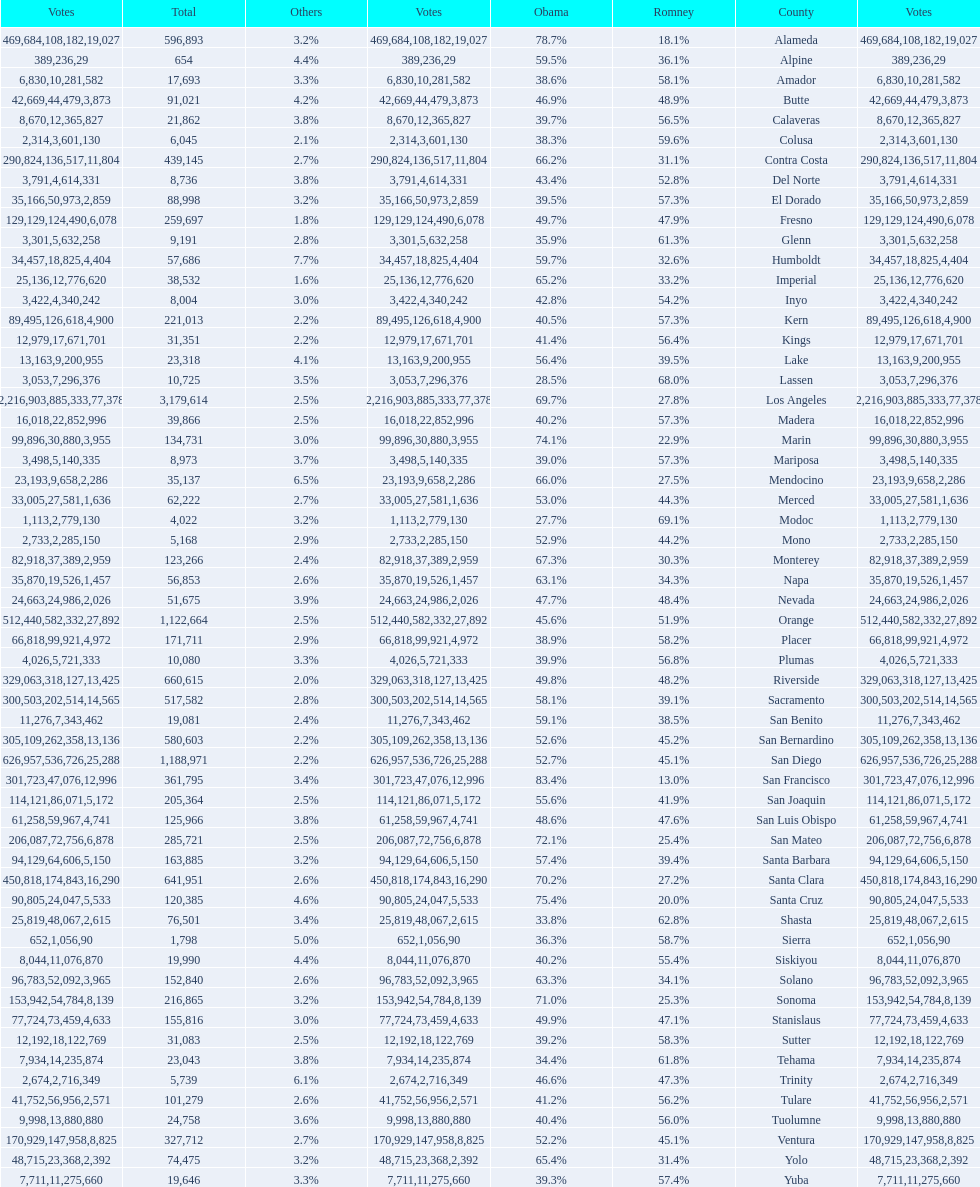What is the number of votes for obama for del norte and el dorado counties? 38957. 